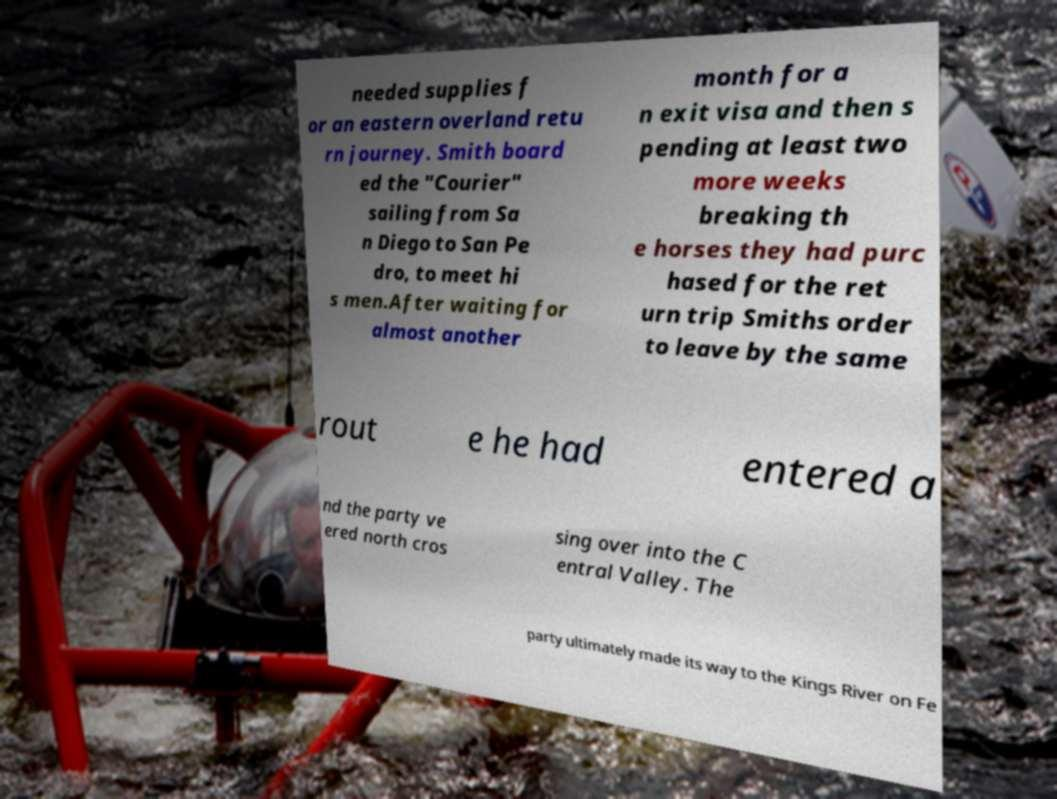Please read and relay the text visible in this image. What does it say? needed supplies f or an eastern overland retu rn journey. Smith board ed the "Courier" sailing from Sa n Diego to San Pe dro, to meet hi s men.After waiting for almost another month for a n exit visa and then s pending at least two more weeks breaking th e horses they had purc hased for the ret urn trip Smiths order to leave by the same rout e he had entered a nd the party ve ered north cros sing over into the C entral Valley. The party ultimately made its way to the Kings River on Fe 